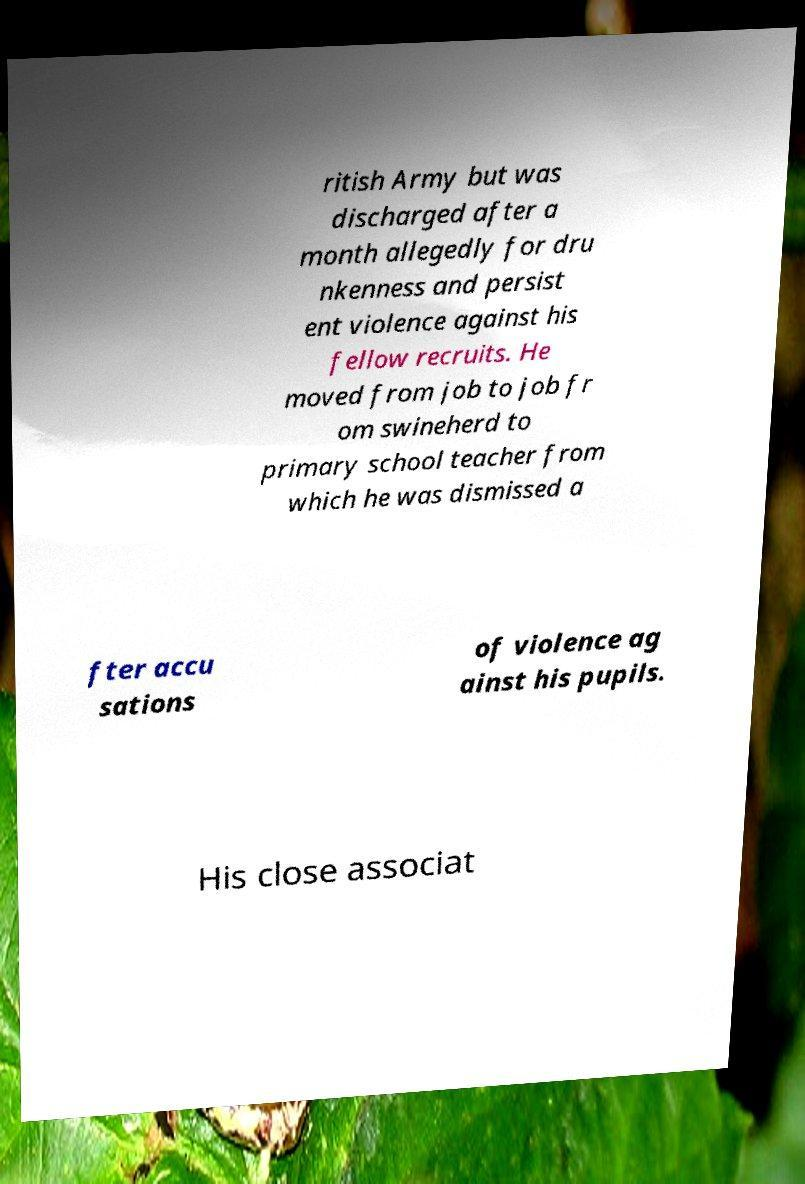What messages or text are displayed in this image? I need them in a readable, typed format. ritish Army but was discharged after a month allegedly for dru nkenness and persist ent violence against his fellow recruits. He moved from job to job fr om swineherd to primary school teacher from which he was dismissed a fter accu sations of violence ag ainst his pupils. His close associat 